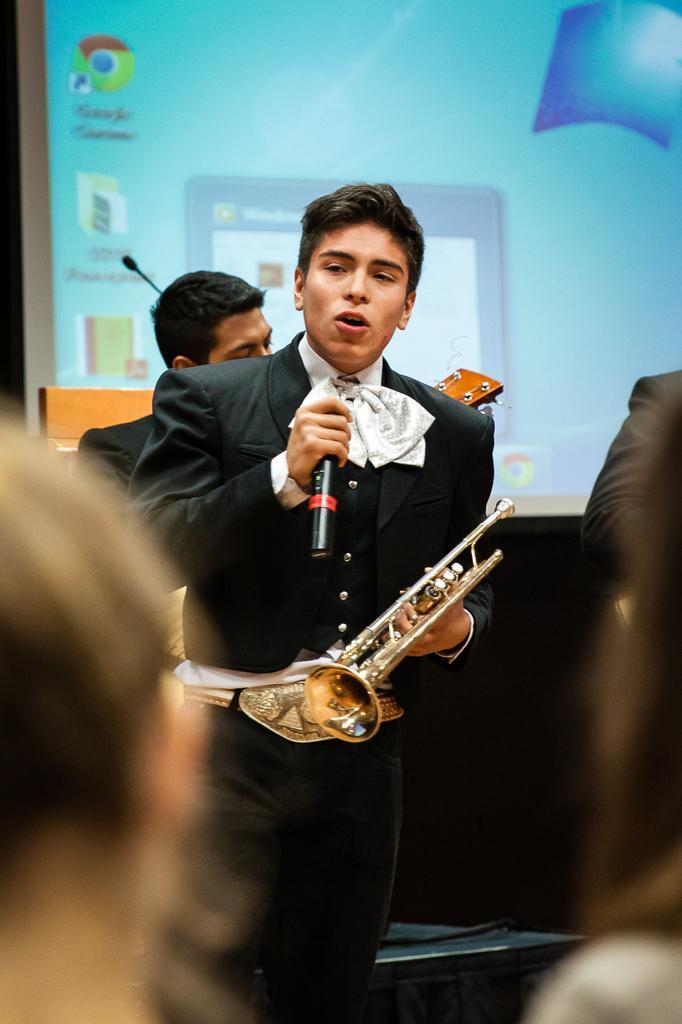In one or two sentences, can you explain what this image depicts? In this image, in the middle there is a boy, he is standing and he is holding a microphone which is in black color in his right hand and he is holding a music instrument which is in yellow color in his left side. In the background there is a man standing and he is holding a music instrument, in the background there is power point projection. 